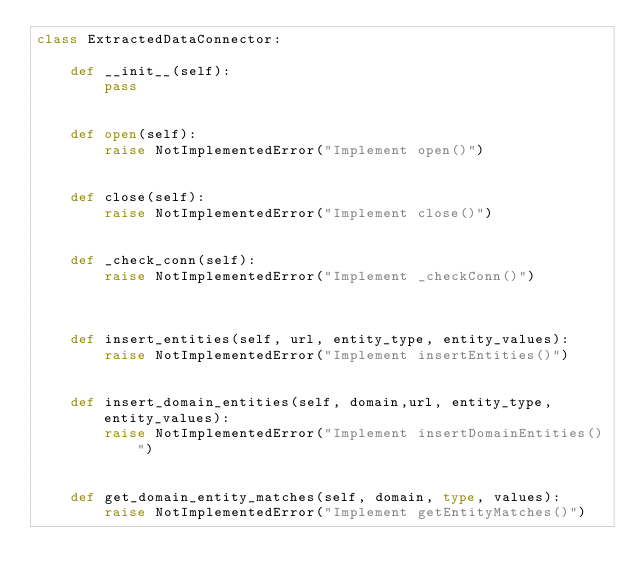<code> <loc_0><loc_0><loc_500><loc_500><_Python_>class ExtractedDataConnector:

    def __init__(self):
        pass


    def open(self):
        raise NotImplementedError("Implement open()")


    def close(self):
        raise NotImplementedError("Implement close()")


    def _check_conn(self):
        raise NotImplementedError("Implement _checkConn()")



    def insert_entities(self, url, entity_type, entity_values):
        raise NotImplementedError("Implement insertEntities()")


    def insert_domain_entities(self, domain,url, entity_type, entity_values):
        raise NotImplementedError("Implement insertDomainEntities()")


    def get_domain_entity_matches(self, domain, type, values):
        raise NotImplementedError("Implement getEntityMatches()")





</code> 